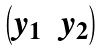<formula> <loc_0><loc_0><loc_500><loc_500>\begin{pmatrix} y _ { 1 } & y _ { 2 } \end{pmatrix}</formula> 